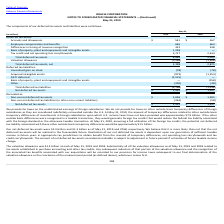According to Oracle Corporation's financial document, Why does Oracle not provide for taxes on other outside basis temporary differences of foreign subsidiaries? We do not provide for taxes on other outside basis temporary differences of foreign subsidiaries as they are considered indefinitely reinvested outside the U.S.. The document states: "he undistributed earnings of foreign subsidiaries. We do not provide for taxes on other outside basis temporary differences of foreign subsidiaries as..." Also, What were the valuation allowances for 2019 related to? Substantially all of the valuation allowances as of May 31, 2019 and 2018 related to tax assets established in purchase accounting and other tax credits.. The document states: "was $1.3 billion at each of May 31, 2019 and 2018. Substantially all of the valuation allowances as of May 31, 2019 and 2018 related to tax assets est..." Also, What are the accruals and allowances for 2019? According to the financial document, $541 (in millions). The relevant text states: "Accruals and allowances $ 541 $ 567..." Also, can you calculate: What is the total accruals and allowances for 2019 and 2018? Based on the calculation: 541+567, the result is 1108 (in millions). This is based on the information: "Accruals and allowances $ 541 $ 567 Accruals and allowances $ 541 $ 567..." The key data points involved are: 541, 567. Also, can you calculate: What is the total employee compensation and benefits for 2019 and 2018? Based on the calculation: 646+664, the result is 1310 (in millions). This is based on the information: "Employee compensation and benefits 646 664 Employee compensation and benefits 646 664..." The key data points involved are: 646, 664. Also, can you calculate: What was the % change in the net deferred tax assets from 2018 to 2019? To answer this question, I need to perform calculations using the financial data. The calculation is: (2,432-1,337)/1,337, which equals 81.9 (percentage). This is based on the information: "Net deferred tax assets $ 2,432 $ 1,337 Net deferred tax assets $ 2,432 $ 1,337..." The key data points involved are: 1,337, 2,432. 